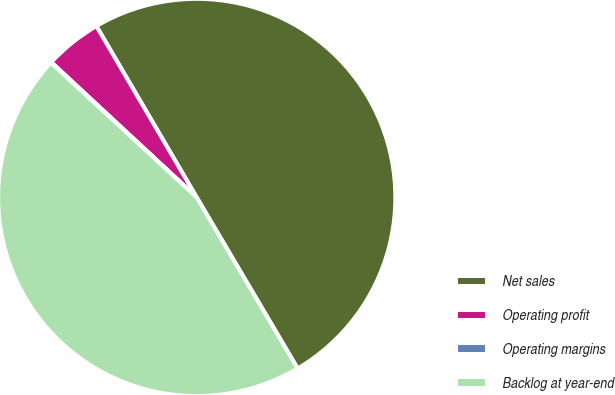<chart> <loc_0><loc_0><loc_500><loc_500><pie_chart><fcel>Net sales<fcel>Operating profit<fcel>Operating margins<fcel>Backlog at year-end<nl><fcel>49.95%<fcel>4.65%<fcel>0.05%<fcel>45.35%<nl></chart> 